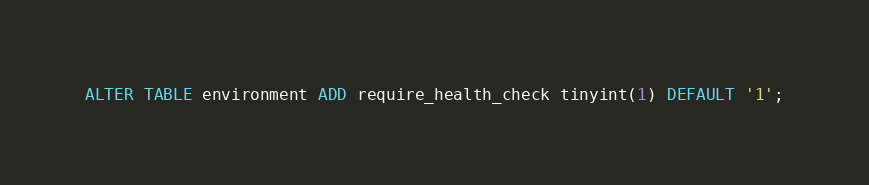Convert code to text. <code><loc_0><loc_0><loc_500><loc_500><_SQL_>ALTER TABLE environment ADD require_health_check tinyint(1) DEFAULT '1';</code> 